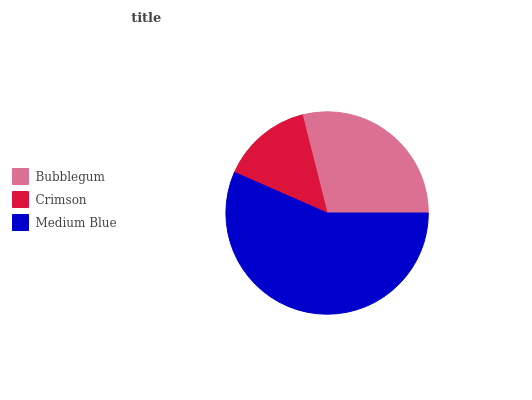Is Crimson the minimum?
Answer yes or no. Yes. Is Medium Blue the maximum?
Answer yes or no. Yes. Is Medium Blue the minimum?
Answer yes or no. No. Is Crimson the maximum?
Answer yes or no. No. Is Medium Blue greater than Crimson?
Answer yes or no. Yes. Is Crimson less than Medium Blue?
Answer yes or no. Yes. Is Crimson greater than Medium Blue?
Answer yes or no. No. Is Medium Blue less than Crimson?
Answer yes or no. No. Is Bubblegum the high median?
Answer yes or no. Yes. Is Bubblegum the low median?
Answer yes or no. Yes. Is Crimson the high median?
Answer yes or no. No. Is Crimson the low median?
Answer yes or no. No. 